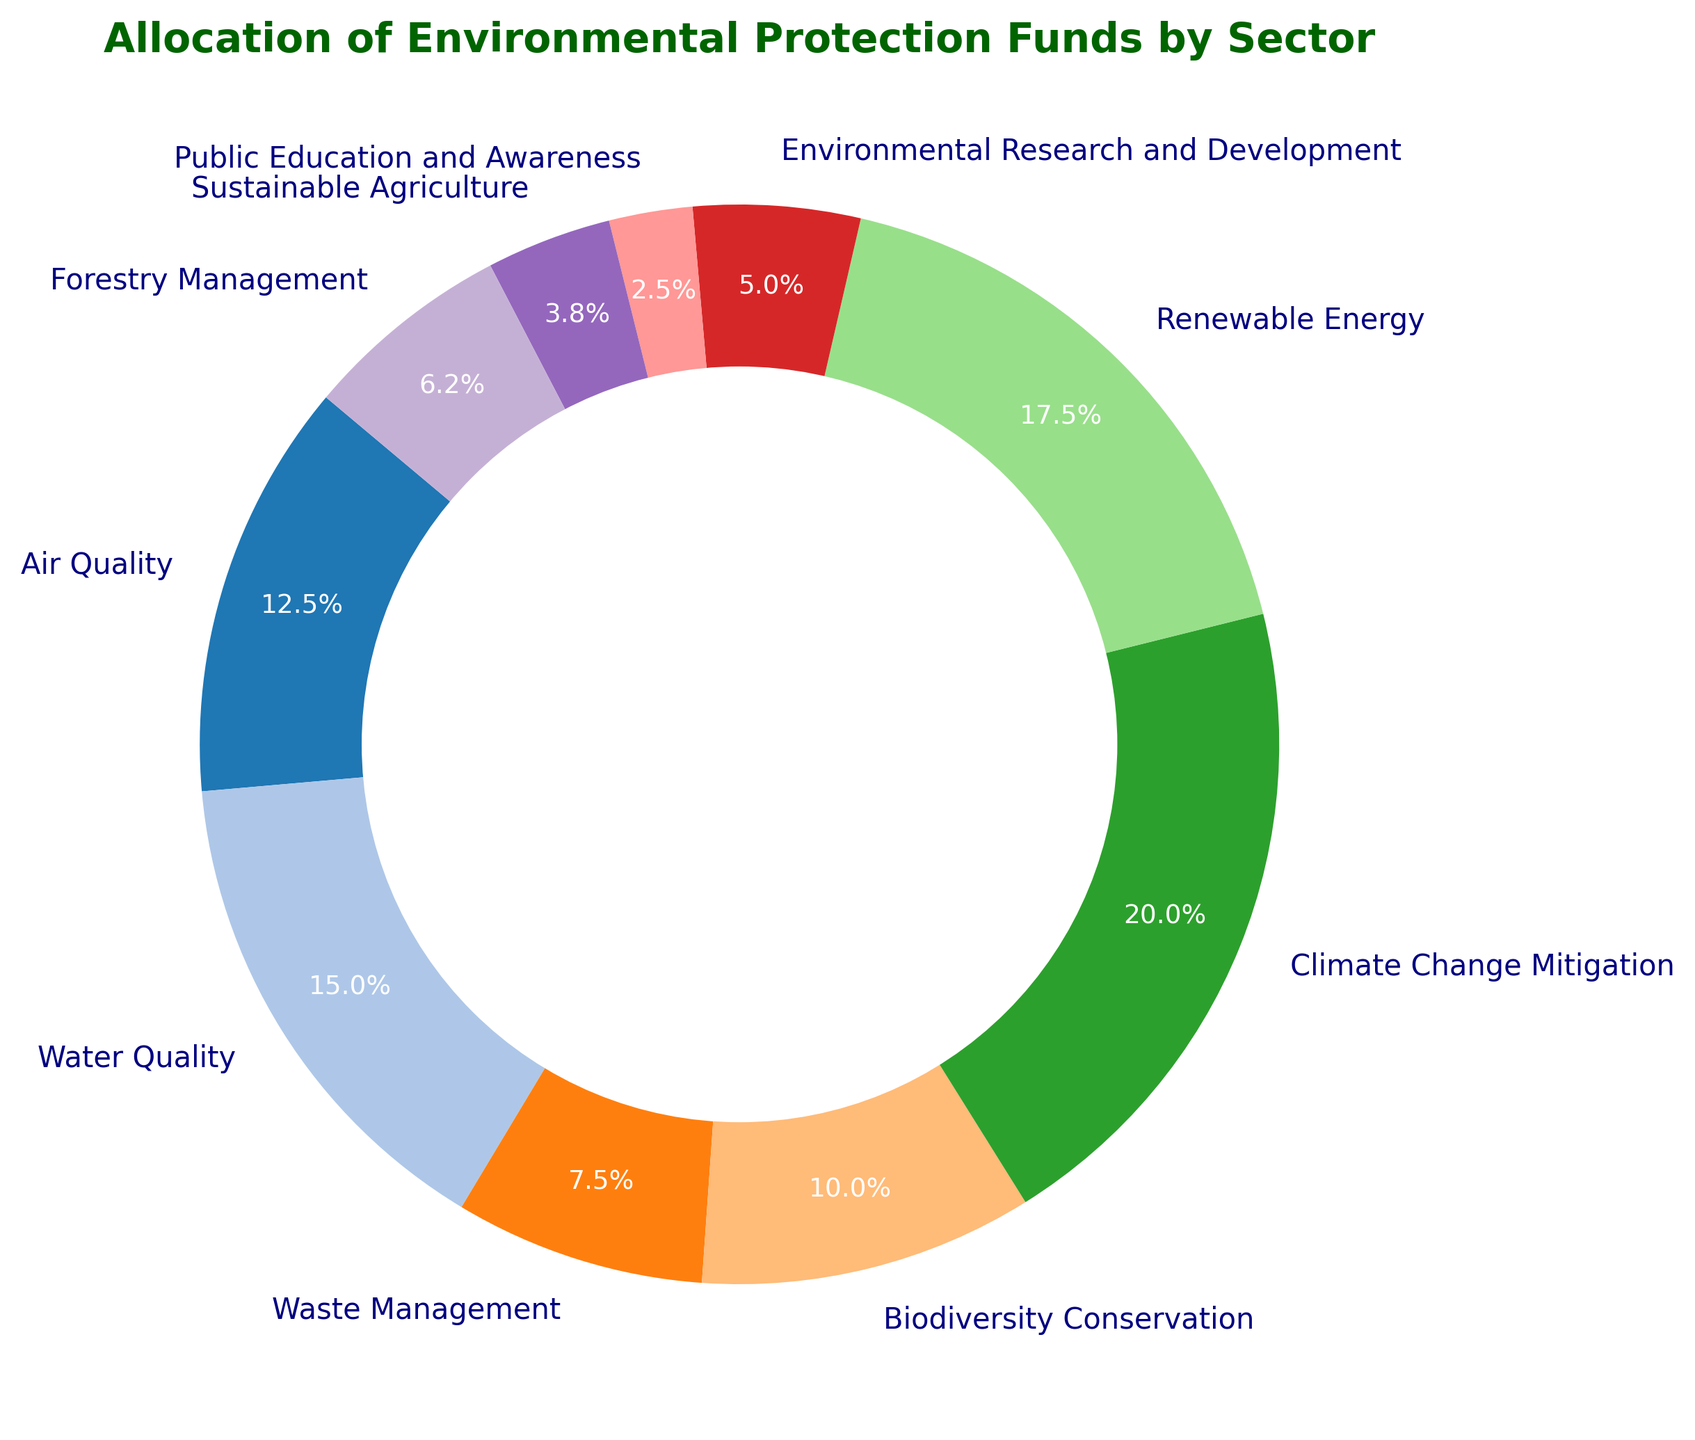What is the total amount allocated to Air Quality and Water Quality sectors combined? To solve this, sum the amounts allocated to Air Quality and Water Quality. Air Quality has $2,500,000 and Water Quality has $3,000,000, so the total allocation is $2,500,000 + $3,000,000 = $5,500,000.
Answer: $5,500,000 Which sector has the lowest allocation of funds? By observing the pie chart, the sector with the smallest percentage is Public Education and Awareness, which has the smallest visual slice.
Answer: Public Education and Awareness How much more is allocated to Climate Change Mitigation compared to Biodiversity Conservation? Subtract the amount of Biodiversity Conservation from Climate Change Mitigation. Climate Change Mitigation has $4,000,000 and Biodiversity Conservation has $2,000,000, so the difference is $4,000,000 - $2,000,000 = $2,000,000.
Answer: $2,000,000 Are there any sectors that have equal allocations? By inspecting the slices of the pie chart, it's evident that no two sectors have equal slices, thus no two sectors have the same allocation.
Answer: No Which sector receives more funding: Renewable Energy or Waste Management? Comparing the slices of the pie chart, Renewable Energy has a larger slice than Waste Management. Renewable Energy receives $3,500,000, whereas Waste Management receives $1,500,000.
Answer: Renewable Energy What is the combined percentage of funds allocated to Climate Change Mitigation and Renewable Energy? Add the percentages for Climate Change Mitigation and Renewable Energy. Climate Change Mitigation = 20.3%, Renewable Energy = 17.8%, so the combined percentage is 20.3% + 17.8% = 38.1%.
Answer: 38.1% Which sectors collectively make up more than half of the total allocation? Identify sectors by adding their percentages until the sum exceeds 50%. Starting with the largest: Climate Change Mitigation (20.3%) + Renewable Energy (17.8%) + Water Quality (15.3%) = 53.4%.
Answer: Climate Change Mitigation, Renewable Energy, Water Quality Which sector's allocation is closest in value to Forestry Management? Compare the allocation amounts visually and numerically. Forestry Management = $1,250,000. Sustainable Agriculture is $750,000, which is closer compared to Environmental Research and Development ($1,000,000).
Answer: Environmental Research and Development What is the visual difference between the slices representing Sustainable Agriculture and Forestry Management? Visually compare the size of the slices. The Forestry Management slice is slightly larger than Sustainable Agriculture, indicating a higher allocation.
Answer: Forestry Management slice is larger How many sectors receive an allocation of $2,000,000 or more? Count sectors with allocations of $2,000,000 or more. Those sectors are Air Quality ($2,500,000), Water Quality ($3,000,000), Biodiversity Conservation ($2,000,000), Climate Change Mitigation ($4,000,000), Renewable Energy ($3,500,000). Total is 5 sectors.
Answer: 5 sectors 